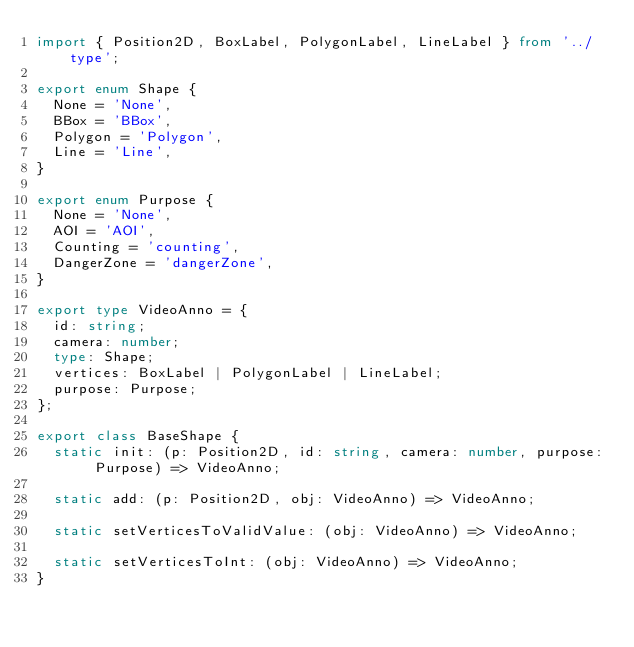<code> <loc_0><loc_0><loc_500><loc_500><_TypeScript_>import { Position2D, BoxLabel, PolygonLabel, LineLabel } from '../type';

export enum Shape {
  None = 'None',
  BBox = 'BBox',
  Polygon = 'Polygon',
  Line = 'Line',
}

export enum Purpose {
  None = 'None',
  AOI = 'AOI',
  Counting = 'counting',
  DangerZone = 'dangerZone',
}

export type VideoAnno = {
  id: string;
  camera: number;
  type: Shape;
  vertices: BoxLabel | PolygonLabel | LineLabel;
  purpose: Purpose;
};

export class BaseShape {
  static init: (p: Position2D, id: string, camera: number, purpose: Purpose) => VideoAnno;

  static add: (p: Position2D, obj: VideoAnno) => VideoAnno;

  static setVerticesToValidValue: (obj: VideoAnno) => VideoAnno;

  static setVerticesToInt: (obj: VideoAnno) => VideoAnno;
}
</code> 